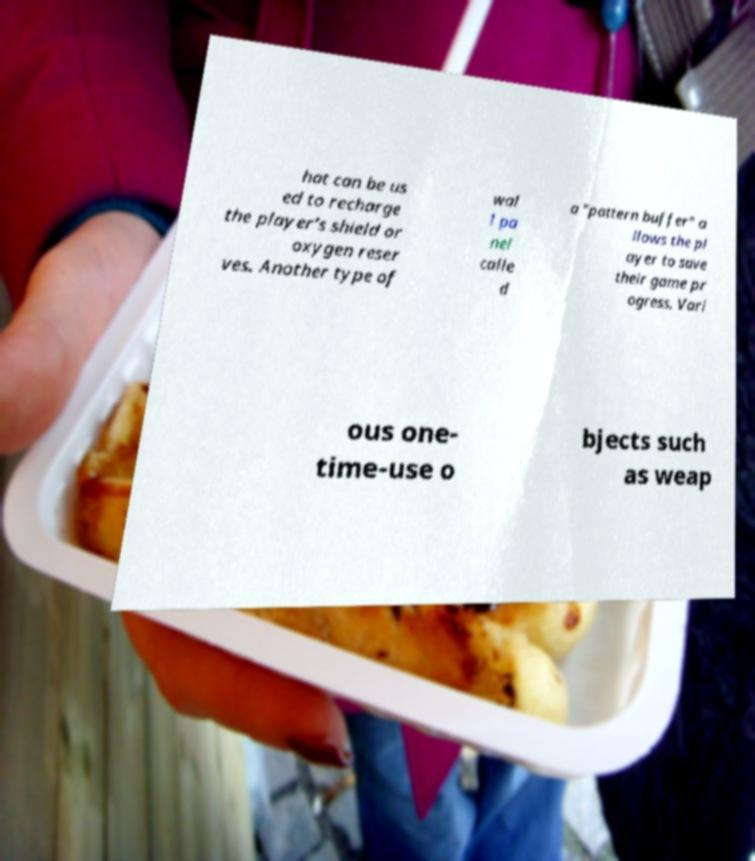Please identify and transcribe the text found in this image. hat can be us ed to recharge the player's shield or oxygen reser ves. Another type of wal l pa nel calle d a "pattern buffer" a llows the pl ayer to save their game pr ogress. Vari ous one- time-use o bjects such as weap 